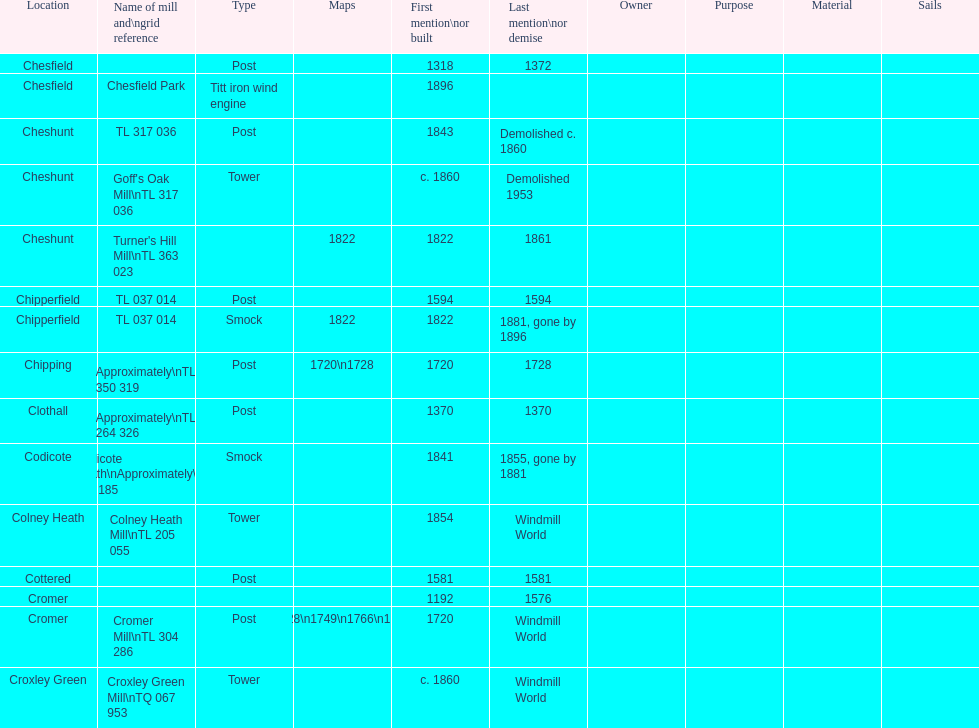Can you parse all the data within this table? {'header': ['Location', 'Name of mill and\\ngrid reference', 'Type', 'Maps', 'First mention\\nor built', 'Last mention\\nor demise', 'Owner', 'Purpose', 'Material', 'Sails'], 'rows': [['Chesfield', '', 'Post', '', '1318', '1372', '', '', '', ''], ['Chesfield', 'Chesfield Park', 'Titt iron wind engine', '', '1896', '', '', '', '', ''], ['Cheshunt', 'TL 317 036', 'Post', '', '1843', 'Demolished c. 1860', '', '', '', ''], ['Cheshunt', "Goff's Oak Mill\\nTL 317 036", 'Tower', '', 'c. 1860', 'Demolished 1953', '', '', '', ''], ['Cheshunt', "Turner's Hill Mill\\nTL 363 023", '', '1822', '1822', '1861', '', '', '', ''], ['Chipperfield', 'TL 037 014', 'Post', '', '1594', '1594', '', '', '', ''], ['Chipperfield', 'TL 037 014', 'Smock', '1822', '1822', '1881, gone by 1896', '', '', '', ''], ['Chipping', 'Approximately\\nTL 350 319', 'Post', '1720\\n1728', '1720', '1728', '', '', '', ''], ['Clothall', 'Approximately\\nTL 264 326', 'Post', '', '1370', '1370', '', '', '', ''], ['Codicote', 'Codicote Heath\\nApproximately\\nTL 206 185', 'Smock', '', '1841', '1855, gone by 1881', '', '', '', ''], ['Colney Heath', 'Colney Heath Mill\\nTL 205 055', 'Tower', '', '1854', 'Windmill World', '', '', '', ''], ['Cottered', '', 'Post', '', '1581', '1581', '', '', '', ''], ['Cromer', '', '', '', '1192', '1576', '', '', '', ''], ['Cromer', 'Cromer Mill\\nTL 304 286', 'Post', '1720\\n1728\\n1749\\n1766\\n1800\\n1822', '1720', 'Windmill World', '', '', '', ''], ['Croxley Green', 'Croxley Green Mill\\nTQ 067 953', 'Tower', '', 'c. 1860', 'Windmill World', '', '', '', '']]} What is the name of the only "c" mill located in colney health? Colney Heath Mill. 